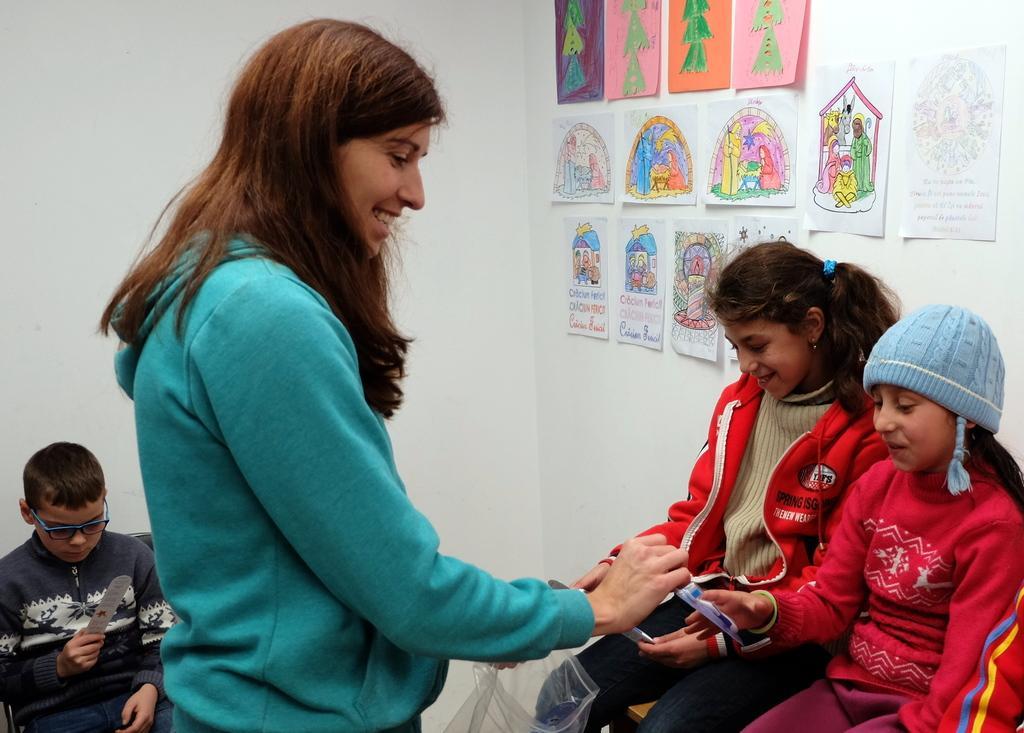Could you give a brief overview of what you see in this image? In a room there is a woman, around her there are three kids and she is giving brushes to each kid. Behind the kids there are photo paints attached to the wall, all the paintings were done on the papers. 